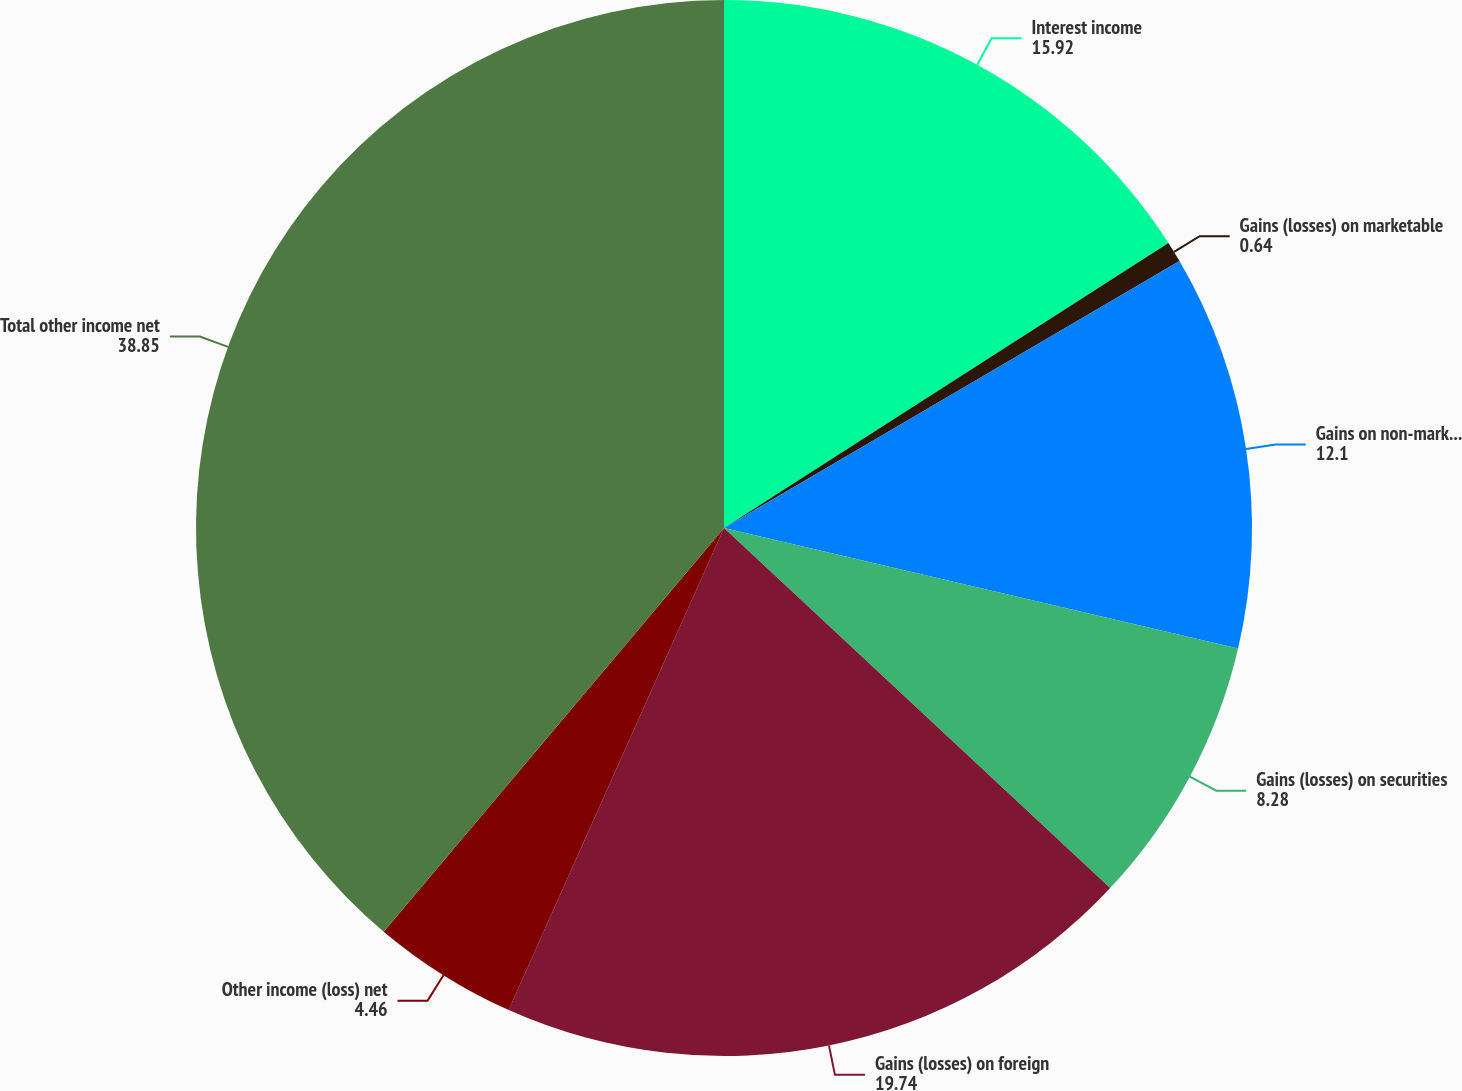<chart> <loc_0><loc_0><loc_500><loc_500><pie_chart><fcel>Interest income<fcel>Gains (losses) on marketable<fcel>Gains on non-marketable equity<fcel>Gains (losses) on securities<fcel>Gains (losses) on foreign<fcel>Other income (loss) net<fcel>Total other income net<nl><fcel>15.92%<fcel>0.64%<fcel>12.1%<fcel>8.28%<fcel>19.74%<fcel>4.46%<fcel>38.85%<nl></chart> 